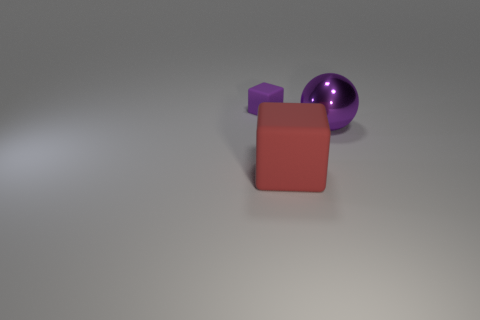Add 1 tiny objects. How many objects exist? 4 Subtract all balls. How many objects are left? 2 Subtract 0 blue cylinders. How many objects are left? 3 Subtract all red objects. Subtract all metal balls. How many objects are left? 1 Add 1 tiny objects. How many tiny objects are left? 2 Add 2 big red things. How many big red things exist? 3 